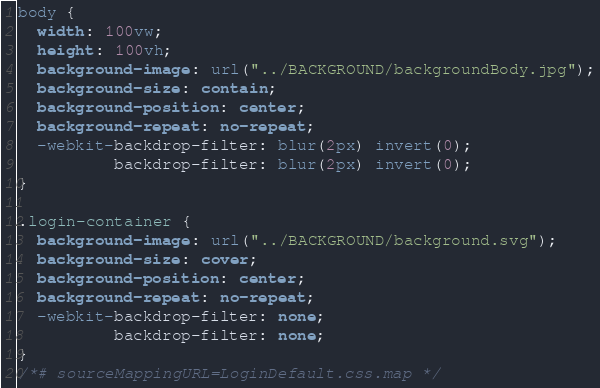Convert code to text. <code><loc_0><loc_0><loc_500><loc_500><_CSS_>
body {
  width: 100vw;
  height: 100vh;
  background-image: url("../BACKGROUND/backgroundBody.jpg");
  background-size: contain;
  background-position: center;
  background-repeat: no-repeat;
  -webkit-backdrop-filter: blur(2px) invert(0);
          backdrop-filter: blur(2px) invert(0);
}

.login-container {
  background-image: url("../BACKGROUND/background.svg");
  background-size: cover;
  background-position: center;
  background-repeat: no-repeat;
  -webkit-backdrop-filter: none;
          backdrop-filter: none;
}
/*# sourceMappingURL=LoginDefault.css.map */</code> 